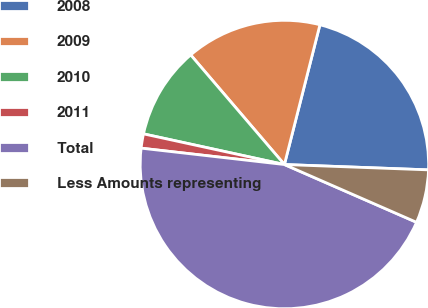Convert chart. <chart><loc_0><loc_0><loc_500><loc_500><pie_chart><fcel>2008<fcel>2009<fcel>2010<fcel>2011<fcel>Total<fcel>Less Amounts representing<nl><fcel>21.63%<fcel>15.22%<fcel>10.33%<fcel>1.6%<fcel>45.25%<fcel>5.97%<nl></chart> 